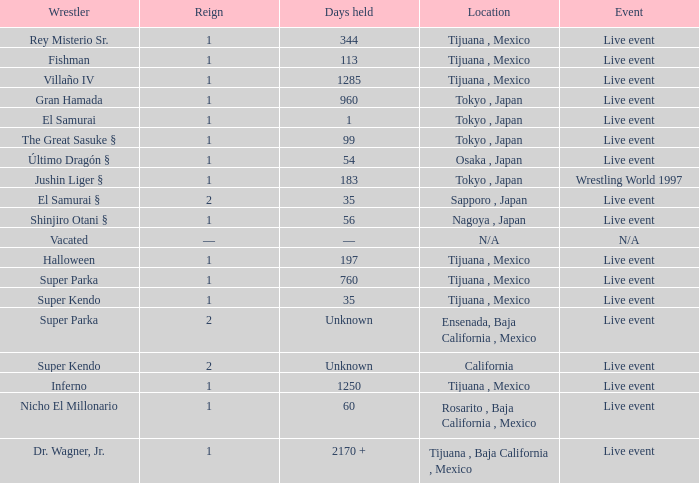What can be said about the reign of the super kendo competitor who maintained their title for 35 days? 1.0. 